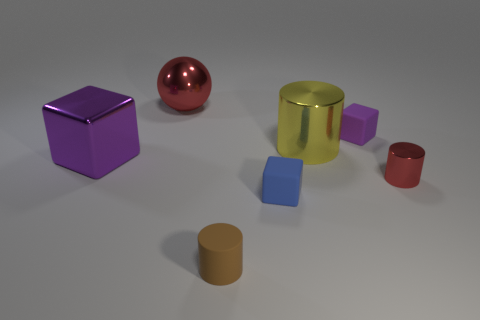Add 1 tiny green cylinders. How many objects exist? 8 Subtract all balls. How many objects are left? 6 Add 4 metallic blocks. How many metallic blocks are left? 5 Add 1 blue objects. How many blue objects exist? 2 Subtract 0 green cylinders. How many objects are left? 7 Subtract all red metallic cylinders. Subtract all tiny purple rubber objects. How many objects are left? 5 